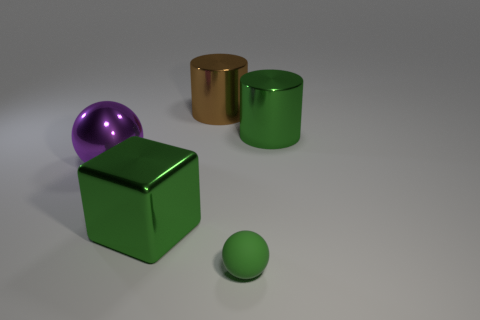Is the color of the large thing right of the big brown object the same as the big block?
Offer a very short reply. Yes. Is there a block of the same color as the small thing?
Give a very brief answer. Yes. There is a ball that is in front of the big metal sphere; is it the same color as the shiny cylinder to the right of the small green sphere?
Provide a succinct answer. Yes. There is a matte object that is the same color as the block; what is its size?
Make the answer very short. Small. Are there any large brown things made of the same material as the cube?
Your answer should be very brief. Yes. Is the number of big shiny spheres in front of the matte ball the same as the number of big metal objects that are right of the purple shiny ball?
Offer a very short reply. No. How big is the ball that is behind the small green matte thing?
Keep it short and to the point. Large. What is the material of the thing in front of the green shiny thing that is on the left side of the green ball?
Offer a terse response. Rubber. There is a big green metallic thing behind the large object that is in front of the purple object; what number of objects are on the left side of it?
Your answer should be compact. 4. Does the big green thing on the right side of the large brown cylinder have the same material as the small green sphere that is in front of the brown metal cylinder?
Provide a succinct answer. No. 